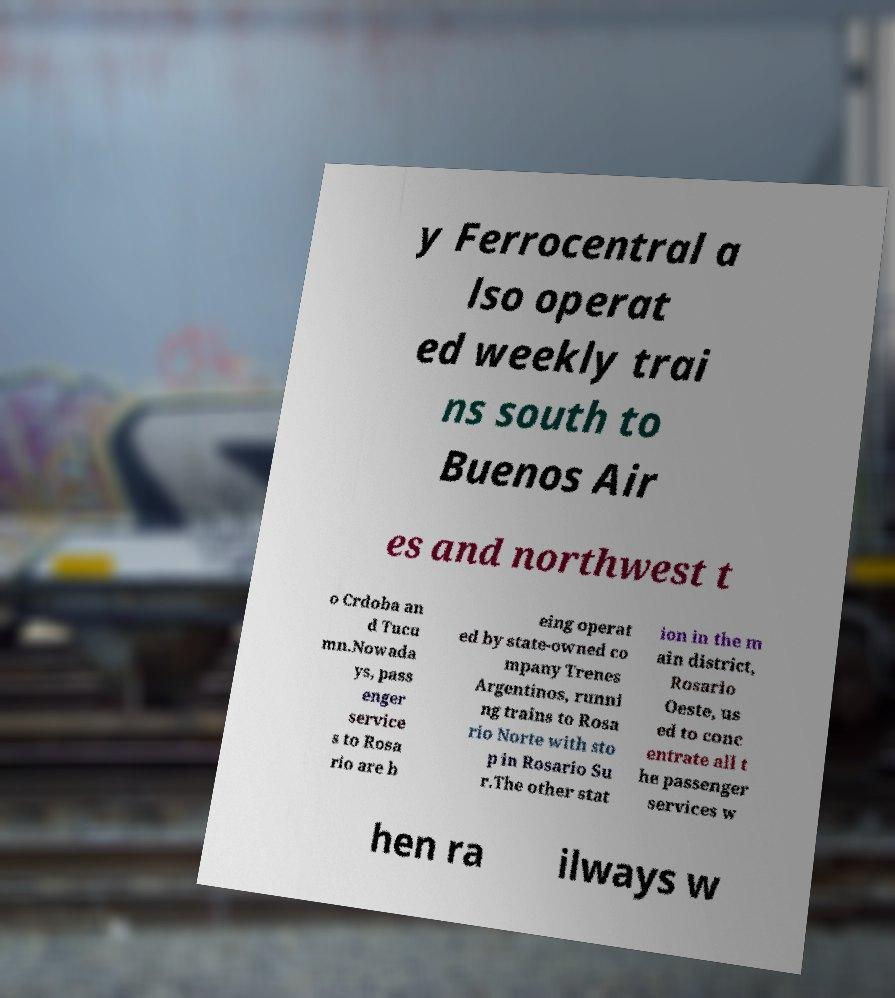Please identify and transcribe the text found in this image. y Ferrocentral a lso operat ed weekly trai ns south to Buenos Air es and northwest t o Crdoba an d Tucu mn.Nowada ys, pass enger service s to Rosa rio are b eing operat ed by state-owned co mpany Trenes Argentinos, runni ng trains to Rosa rio Norte with sto p in Rosario Su r.The other stat ion in the m ain district, Rosario Oeste, us ed to conc entrate all t he passenger services w hen ra ilways w 